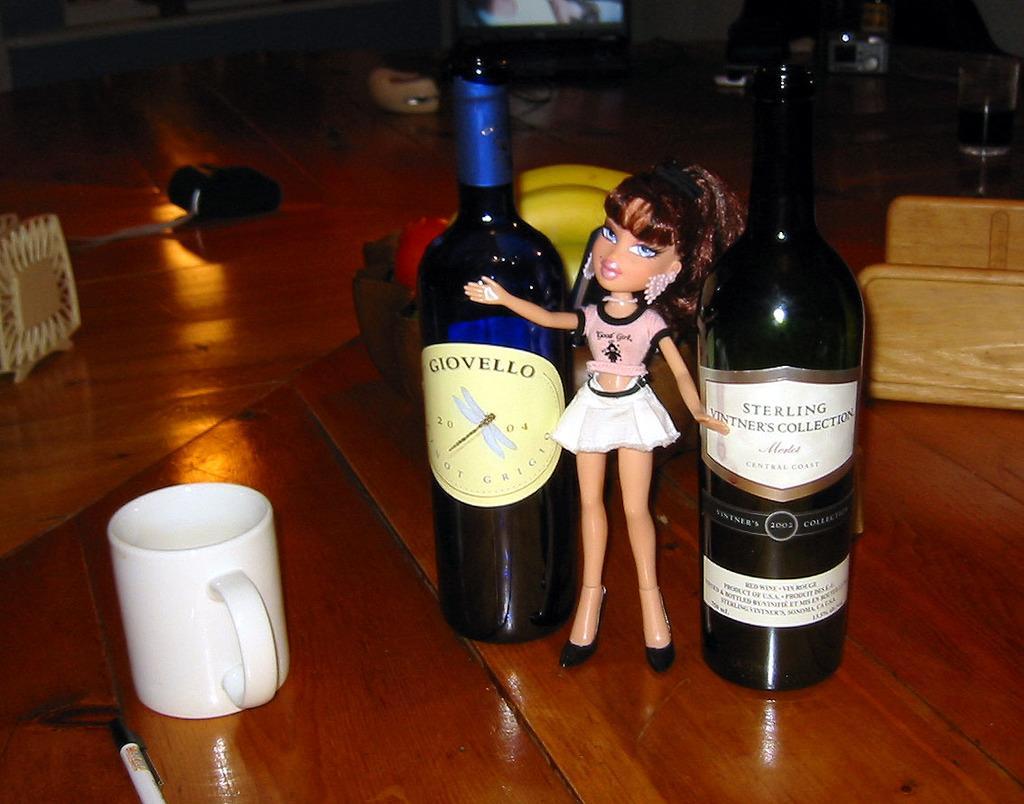Describe this image in one or two sentences. In this image I can see few bottles, cup, toy doll and few objects on the brown color surface. 